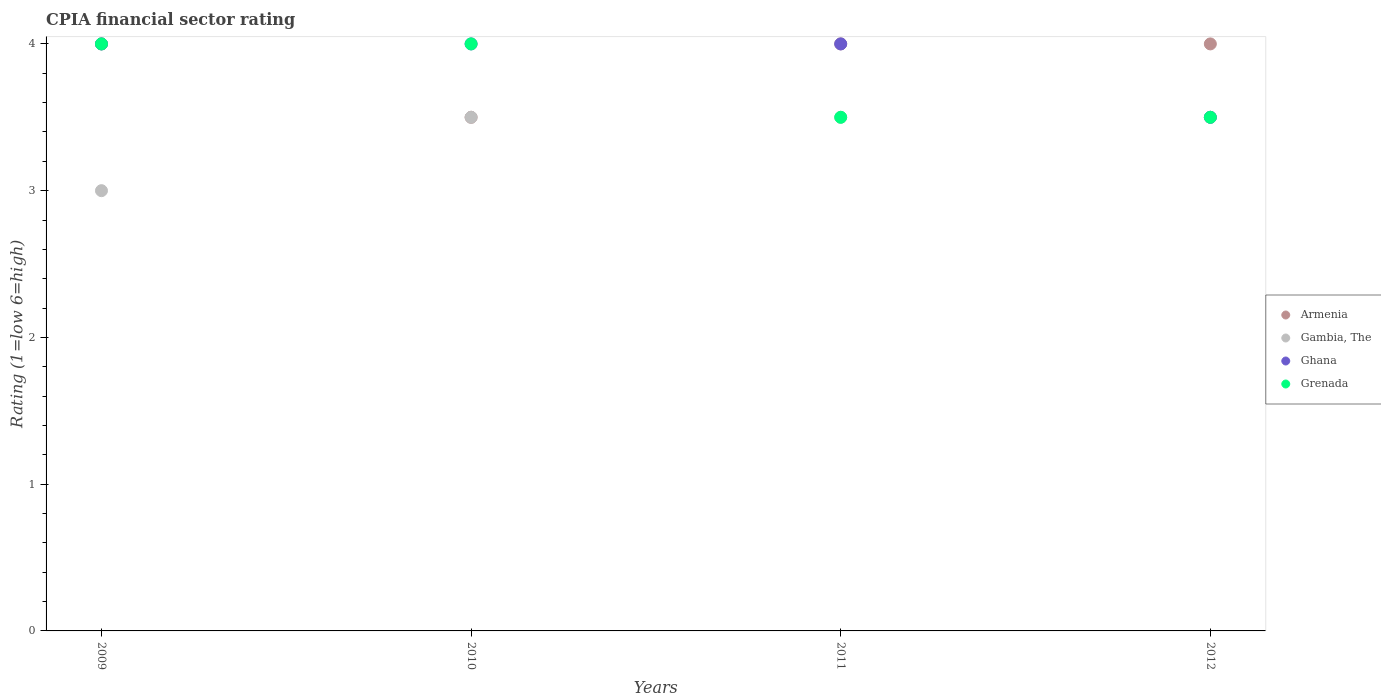How many different coloured dotlines are there?
Your answer should be compact. 4. What is the CPIA rating in Ghana in 2009?
Your answer should be compact. 4. Across all years, what is the maximum CPIA rating in Armenia?
Make the answer very short. 4. Across all years, what is the minimum CPIA rating in Grenada?
Give a very brief answer. 3.5. In which year was the CPIA rating in Armenia maximum?
Your response must be concise. 2009. In which year was the CPIA rating in Gambia, The minimum?
Make the answer very short. 2009. What is the total CPIA rating in Gambia, The in the graph?
Your answer should be compact. 13.5. What is the difference between the CPIA rating in Ghana in 2009 and that in 2010?
Your response must be concise. 0. What is the difference between the CPIA rating in Gambia, The in 2011 and the CPIA rating in Armenia in 2010?
Your answer should be compact. 0. What is the average CPIA rating in Ghana per year?
Your answer should be very brief. 3.88. Is the difference between the CPIA rating in Ghana in 2011 and 2012 greater than the difference between the CPIA rating in Gambia, The in 2011 and 2012?
Make the answer very short. Yes. What is the difference between the highest and the second highest CPIA rating in Ghana?
Give a very brief answer. 0. What is the difference between the highest and the lowest CPIA rating in Grenada?
Offer a terse response. 0.5. In how many years, is the CPIA rating in Gambia, The greater than the average CPIA rating in Gambia, The taken over all years?
Provide a short and direct response. 3. Is the sum of the CPIA rating in Gambia, The in 2009 and 2012 greater than the maximum CPIA rating in Ghana across all years?
Make the answer very short. Yes. Is it the case that in every year, the sum of the CPIA rating in Grenada and CPIA rating in Armenia  is greater than the sum of CPIA rating in Gambia, The and CPIA rating in Ghana?
Your answer should be very brief. Yes. Does the CPIA rating in Grenada monotonically increase over the years?
Make the answer very short. No. Is the CPIA rating in Ghana strictly greater than the CPIA rating in Grenada over the years?
Provide a succinct answer. No. Is the CPIA rating in Ghana strictly less than the CPIA rating in Gambia, The over the years?
Your answer should be very brief. No. How many years are there in the graph?
Your response must be concise. 4. What is the difference between two consecutive major ticks on the Y-axis?
Your answer should be very brief. 1. Where does the legend appear in the graph?
Offer a very short reply. Center right. How many legend labels are there?
Your answer should be very brief. 4. How are the legend labels stacked?
Give a very brief answer. Vertical. What is the title of the graph?
Your response must be concise. CPIA financial sector rating. Does "Poland" appear as one of the legend labels in the graph?
Your answer should be very brief. No. What is the Rating (1=low 6=high) in Armenia in 2009?
Ensure brevity in your answer.  4. What is the Rating (1=low 6=high) in Ghana in 2009?
Provide a succinct answer. 4. What is the Rating (1=low 6=high) of Grenada in 2009?
Provide a succinct answer. 4. What is the Rating (1=low 6=high) of Armenia in 2010?
Make the answer very short. 3.5. What is the Rating (1=low 6=high) in Ghana in 2011?
Your answer should be compact. 4. What is the Rating (1=low 6=high) of Grenada in 2011?
Your answer should be very brief. 3.5. What is the Rating (1=low 6=high) of Gambia, The in 2012?
Give a very brief answer. 3.5. Across all years, what is the maximum Rating (1=low 6=high) of Armenia?
Your response must be concise. 4. Across all years, what is the maximum Rating (1=low 6=high) of Gambia, The?
Ensure brevity in your answer.  3.5. Across all years, what is the maximum Rating (1=low 6=high) in Grenada?
Provide a short and direct response. 4. Across all years, what is the minimum Rating (1=low 6=high) in Gambia, The?
Keep it short and to the point. 3. Across all years, what is the minimum Rating (1=low 6=high) of Grenada?
Offer a very short reply. 3.5. What is the total Rating (1=low 6=high) of Ghana in the graph?
Ensure brevity in your answer.  15.5. What is the difference between the Rating (1=low 6=high) in Armenia in 2009 and that in 2010?
Ensure brevity in your answer.  0.5. What is the difference between the Rating (1=low 6=high) of Gambia, The in 2009 and that in 2010?
Keep it short and to the point. -0.5. What is the difference between the Rating (1=low 6=high) in Ghana in 2009 and that in 2010?
Make the answer very short. 0. What is the difference between the Rating (1=low 6=high) of Armenia in 2009 and that in 2011?
Your answer should be compact. 0. What is the difference between the Rating (1=low 6=high) of Ghana in 2009 and that in 2011?
Give a very brief answer. 0. What is the difference between the Rating (1=low 6=high) in Grenada in 2009 and that in 2012?
Your response must be concise. 0.5. What is the difference between the Rating (1=low 6=high) of Armenia in 2010 and that in 2011?
Keep it short and to the point. -0.5. What is the difference between the Rating (1=low 6=high) of Grenada in 2010 and that in 2011?
Your response must be concise. 0.5. What is the difference between the Rating (1=low 6=high) of Ghana in 2010 and that in 2012?
Your answer should be compact. 0.5. What is the difference between the Rating (1=low 6=high) of Gambia, The in 2011 and that in 2012?
Offer a very short reply. 0. What is the difference between the Rating (1=low 6=high) of Ghana in 2011 and that in 2012?
Offer a very short reply. 0.5. What is the difference between the Rating (1=low 6=high) of Grenada in 2011 and that in 2012?
Offer a very short reply. 0. What is the difference between the Rating (1=low 6=high) of Armenia in 2009 and the Rating (1=low 6=high) of Grenada in 2010?
Give a very brief answer. 0. What is the difference between the Rating (1=low 6=high) in Gambia, The in 2009 and the Rating (1=low 6=high) in Ghana in 2010?
Your answer should be very brief. -1. What is the difference between the Rating (1=low 6=high) of Armenia in 2009 and the Rating (1=low 6=high) of Ghana in 2011?
Offer a terse response. 0. What is the difference between the Rating (1=low 6=high) of Armenia in 2009 and the Rating (1=low 6=high) of Grenada in 2011?
Offer a terse response. 0.5. What is the difference between the Rating (1=low 6=high) of Ghana in 2009 and the Rating (1=low 6=high) of Grenada in 2011?
Give a very brief answer. 0.5. What is the difference between the Rating (1=low 6=high) in Armenia in 2009 and the Rating (1=low 6=high) in Ghana in 2012?
Ensure brevity in your answer.  0.5. What is the difference between the Rating (1=low 6=high) in Armenia in 2010 and the Rating (1=low 6=high) in Gambia, The in 2011?
Offer a very short reply. 0. What is the difference between the Rating (1=low 6=high) in Armenia in 2010 and the Rating (1=low 6=high) in Ghana in 2011?
Give a very brief answer. -0.5. What is the difference between the Rating (1=low 6=high) in Armenia in 2010 and the Rating (1=low 6=high) in Grenada in 2011?
Your response must be concise. 0. What is the difference between the Rating (1=low 6=high) of Gambia, The in 2010 and the Rating (1=low 6=high) of Ghana in 2011?
Provide a short and direct response. -0.5. What is the difference between the Rating (1=low 6=high) of Gambia, The in 2010 and the Rating (1=low 6=high) of Grenada in 2011?
Keep it short and to the point. 0. What is the difference between the Rating (1=low 6=high) in Ghana in 2010 and the Rating (1=low 6=high) in Grenada in 2011?
Make the answer very short. 0.5. What is the difference between the Rating (1=low 6=high) in Armenia in 2010 and the Rating (1=low 6=high) in Gambia, The in 2012?
Provide a short and direct response. 0. What is the difference between the Rating (1=low 6=high) in Armenia in 2010 and the Rating (1=low 6=high) in Ghana in 2012?
Ensure brevity in your answer.  0. What is the difference between the Rating (1=low 6=high) in Gambia, The in 2010 and the Rating (1=low 6=high) in Ghana in 2012?
Keep it short and to the point. 0. What is the difference between the Rating (1=low 6=high) in Gambia, The in 2010 and the Rating (1=low 6=high) in Grenada in 2012?
Give a very brief answer. 0. What is the difference between the Rating (1=low 6=high) of Ghana in 2010 and the Rating (1=low 6=high) of Grenada in 2012?
Provide a succinct answer. 0.5. What is the difference between the Rating (1=low 6=high) of Armenia in 2011 and the Rating (1=low 6=high) of Ghana in 2012?
Ensure brevity in your answer.  0.5. What is the difference between the Rating (1=low 6=high) of Armenia in 2011 and the Rating (1=low 6=high) of Grenada in 2012?
Your response must be concise. 0.5. What is the difference between the Rating (1=low 6=high) of Gambia, The in 2011 and the Rating (1=low 6=high) of Ghana in 2012?
Offer a very short reply. 0. What is the average Rating (1=low 6=high) of Armenia per year?
Ensure brevity in your answer.  3.88. What is the average Rating (1=low 6=high) of Gambia, The per year?
Provide a succinct answer. 3.38. What is the average Rating (1=low 6=high) of Ghana per year?
Your answer should be compact. 3.88. What is the average Rating (1=low 6=high) in Grenada per year?
Your response must be concise. 3.75. In the year 2009, what is the difference between the Rating (1=low 6=high) in Armenia and Rating (1=low 6=high) in Ghana?
Your answer should be compact. 0. In the year 2009, what is the difference between the Rating (1=low 6=high) of Armenia and Rating (1=low 6=high) of Grenada?
Provide a succinct answer. 0. In the year 2009, what is the difference between the Rating (1=low 6=high) in Gambia, The and Rating (1=low 6=high) in Ghana?
Your answer should be compact. -1. In the year 2010, what is the difference between the Rating (1=low 6=high) in Armenia and Rating (1=low 6=high) in Gambia, The?
Your answer should be compact. 0. In the year 2010, what is the difference between the Rating (1=low 6=high) of Armenia and Rating (1=low 6=high) of Grenada?
Keep it short and to the point. -0.5. In the year 2010, what is the difference between the Rating (1=low 6=high) in Gambia, The and Rating (1=low 6=high) in Ghana?
Keep it short and to the point. -0.5. In the year 2010, what is the difference between the Rating (1=low 6=high) in Ghana and Rating (1=low 6=high) in Grenada?
Give a very brief answer. 0. In the year 2011, what is the difference between the Rating (1=low 6=high) in Armenia and Rating (1=low 6=high) in Gambia, The?
Your response must be concise. 0.5. In the year 2011, what is the difference between the Rating (1=low 6=high) of Ghana and Rating (1=low 6=high) of Grenada?
Offer a terse response. 0.5. In the year 2012, what is the difference between the Rating (1=low 6=high) in Armenia and Rating (1=low 6=high) in Gambia, The?
Keep it short and to the point. 0.5. In the year 2012, what is the difference between the Rating (1=low 6=high) of Gambia, The and Rating (1=low 6=high) of Grenada?
Your answer should be compact. 0. In the year 2012, what is the difference between the Rating (1=low 6=high) of Ghana and Rating (1=low 6=high) of Grenada?
Ensure brevity in your answer.  0. What is the ratio of the Rating (1=low 6=high) of Gambia, The in 2009 to that in 2010?
Ensure brevity in your answer.  0.86. What is the ratio of the Rating (1=low 6=high) of Ghana in 2009 to that in 2010?
Your answer should be compact. 1. What is the ratio of the Rating (1=low 6=high) in Grenada in 2009 to that in 2010?
Your response must be concise. 1. What is the ratio of the Rating (1=low 6=high) of Armenia in 2009 to that in 2011?
Your answer should be compact. 1. What is the ratio of the Rating (1=low 6=high) of Grenada in 2009 to that in 2011?
Make the answer very short. 1.14. What is the ratio of the Rating (1=low 6=high) in Armenia in 2009 to that in 2012?
Provide a succinct answer. 1. What is the ratio of the Rating (1=low 6=high) of Gambia, The in 2009 to that in 2012?
Make the answer very short. 0.86. What is the ratio of the Rating (1=low 6=high) in Ghana in 2009 to that in 2012?
Keep it short and to the point. 1.14. What is the ratio of the Rating (1=low 6=high) in Armenia in 2010 to that in 2011?
Provide a succinct answer. 0.88. What is the ratio of the Rating (1=low 6=high) of Gambia, The in 2010 to that in 2011?
Your response must be concise. 1. What is the ratio of the Rating (1=low 6=high) of Ghana in 2010 to that in 2011?
Your response must be concise. 1. What is the ratio of the Rating (1=low 6=high) of Armenia in 2010 to that in 2012?
Your answer should be compact. 0.88. What is the ratio of the Rating (1=low 6=high) in Gambia, The in 2010 to that in 2012?
Provide a short and direct response. 1. What is the ratio of the Rating (1=low 6=high) in Grenada in 2010 to that in 2012?
Your answer should be compact. 1.14. What is the ratio of the Rating (1=low 6=high) of Ghana in 2011 to that in 2012?
Provide a short and direct response. 1.14. What is the difference between the highest and the second highest Rating (1=low 6=high) in Armenia?
Your answer should be compact. 0. What is the difference between the highest and the second highest Rating (1=low 6=high) of Gambia, The?
Ensure brevity in your answer.  0. What is the difference between the highest and the second highest Rating (1=low 6=high) of Ghana?
Your answer should be compact. 0. What is the difference between the highest and the lowest Rating (1=low 6=high) of Gambia, The?
Make the answer very short. 0.5. 